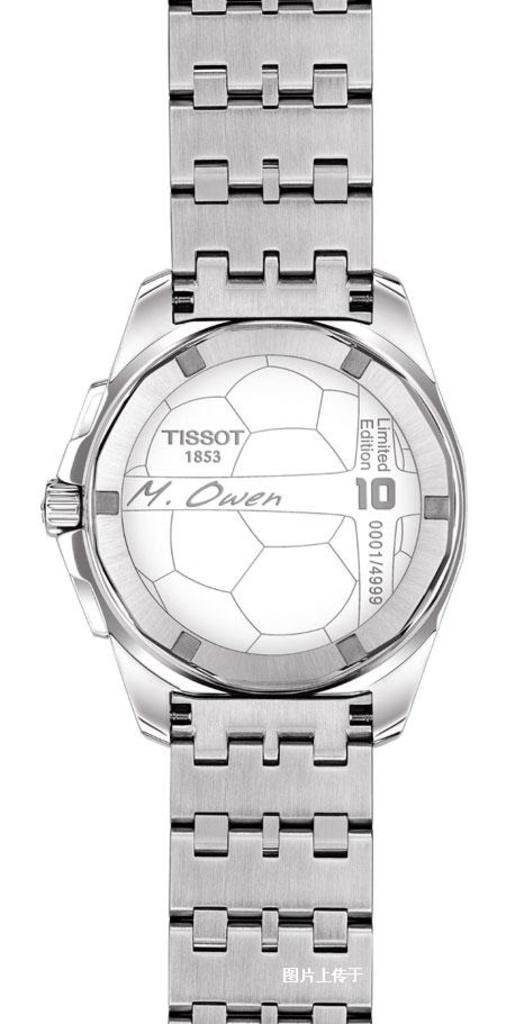Provide a one-sentence caption for the provided image. A silver TISSOT 1853 M. Owen wrist watch. 